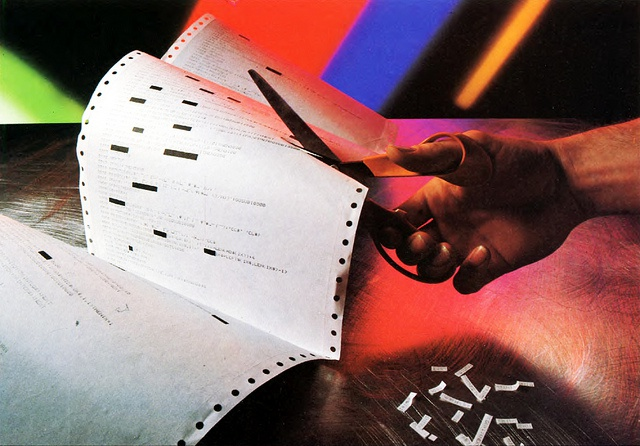Describe the objects in this image and their specific colors. I can see people in black, maroon, and brown tones, book in black and blue tones, scissors in black, maroon, lightpink, and brown tones, and book in black, orange, red, and maroon tones in this image. 